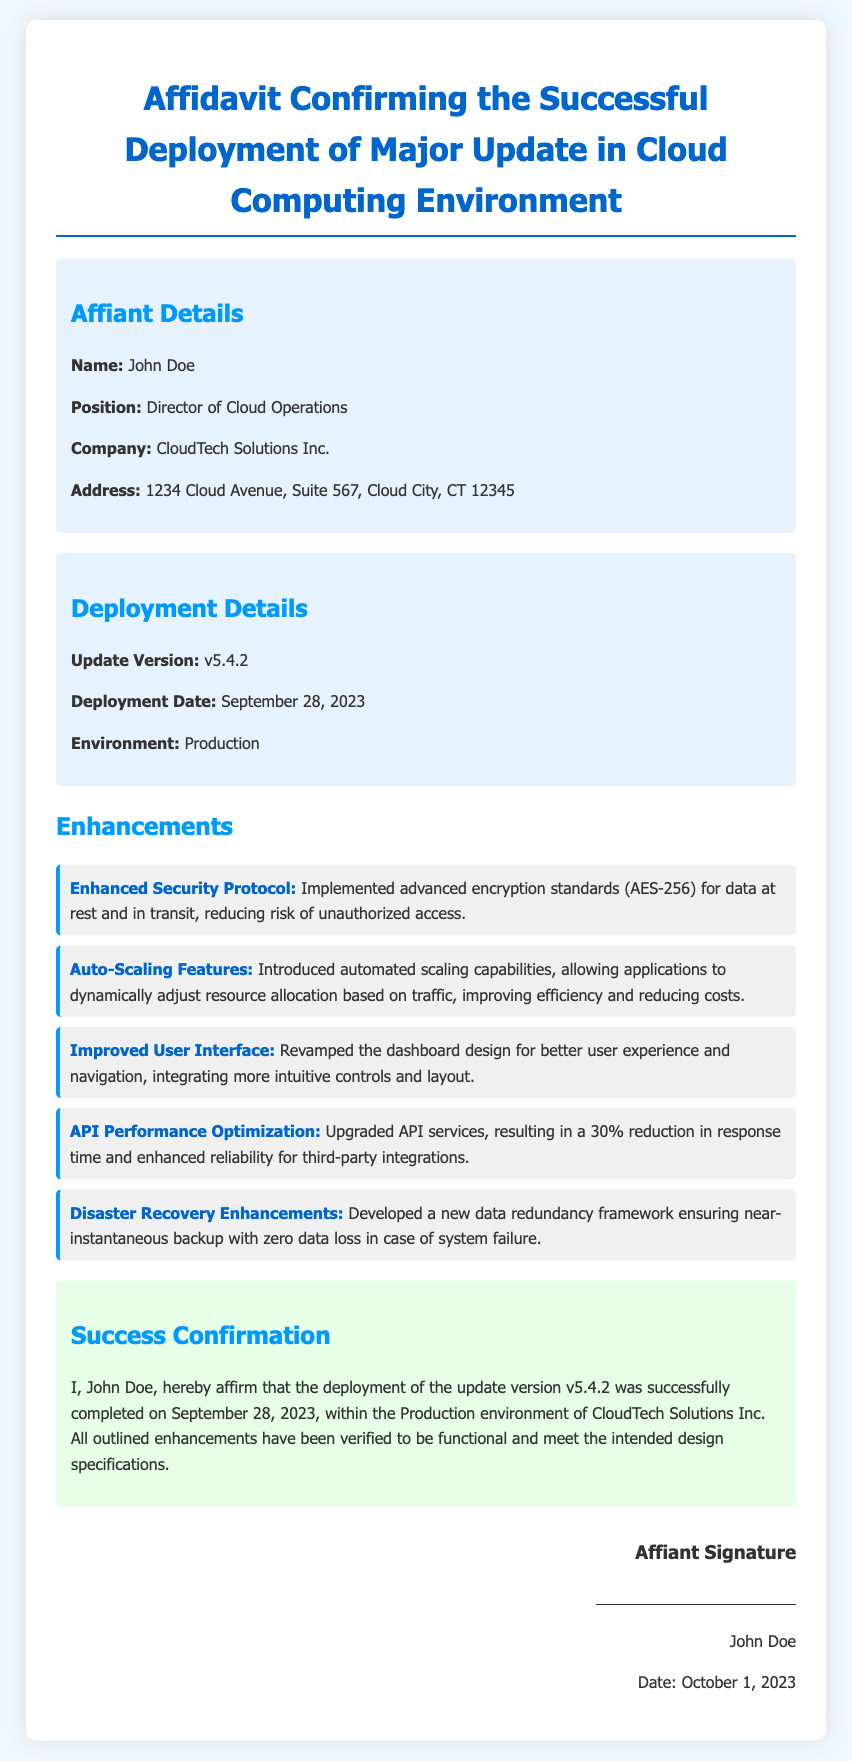What is the name of the affiant? The affiant is the individual affirming the information in the affidavit, which is mentioned as John Doe.
Answer: John Doe What is the update version mentioned in the document? The document specifies the version of the update that was deployed as v5.4.2.
Answer: v5.4.2 When was the deployment successfully completed? The deployment date is indicated in the document, which is September 28, 2023.
Answer: September 28, 2023 What is one of the enhancements made in this update? The document lists several enhancements, and one example is "Enhanced Security Protocol".
Answer: Enhanced Security Protocol What is the position of the affiant? The affiant's job title as stated in the document is Director of Cloud Operations.
Answer: Director of Cloud Operations What environment was this update deployed to? The environment for the deployment specified in the affidavit is Production.
Answer: Production What percentage reduction in response time is achieved through API performance optimization? The affidavit states a 30% reduction in response time due to the enhancements made.
Answer: 30% What does the affiant confirm about the functionality of the enhancements? The affiant affirms that all outlined enhancements have been verified to be functional and meet the intended design specifications.
Answer: Functional On what date was the affiant's signature dated? The signature section of the document indicates that the signature was dated October 1, 2023.
Answer: October 1, 2023 